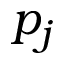<formula> <loc_0><loc_0><loc_500><loc_500>p _ { j }</formula> 